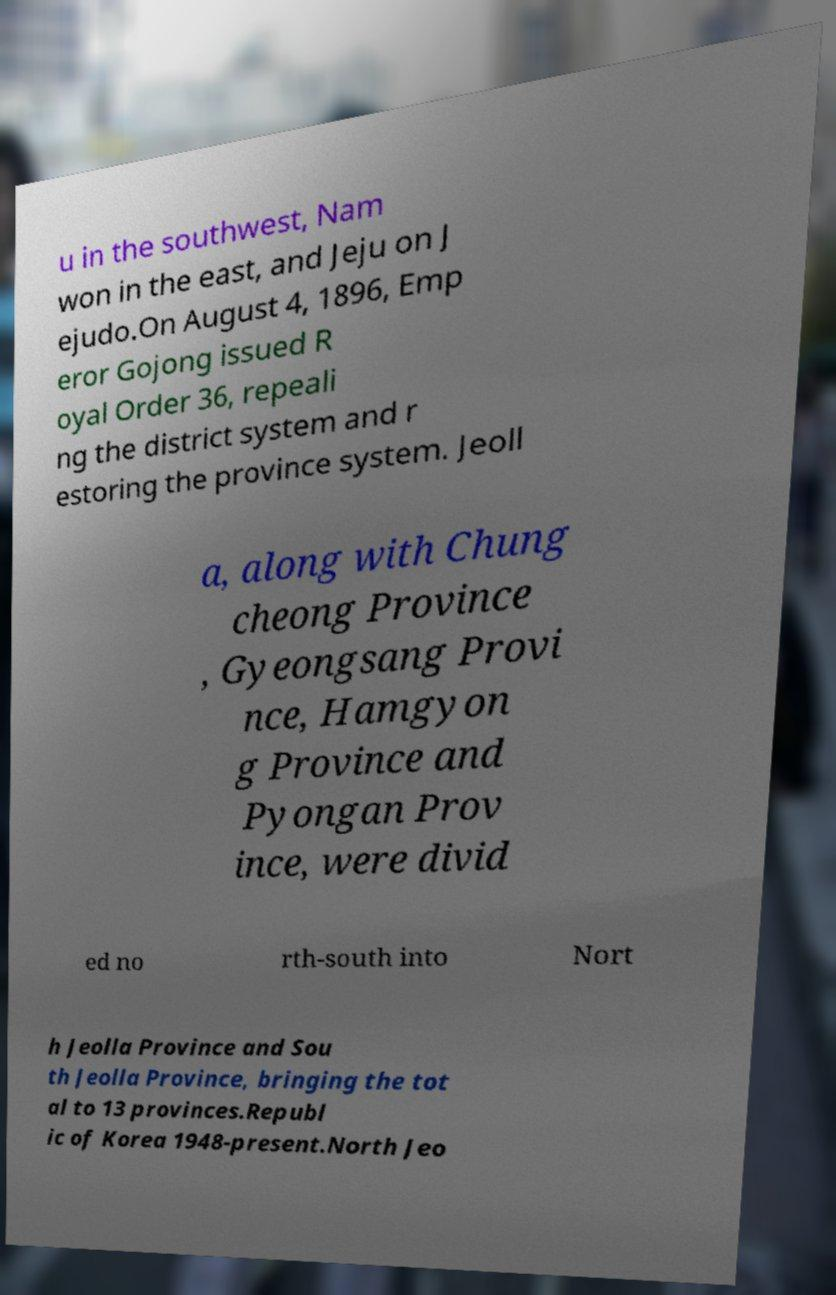For documentation purposes, I need the text within this image transcribed. Could you provide that? u in the southwest, Nam won in the east, and Jeju on J ejudo.On August 4, 1896, Emp eror Gojong issued R oyal Order 36, repeali ng the district system and r estoring the province system. Jeoll a, along with Chung cheong Province , Gyeongsang Provi nce, Hamgyon g Province and Pyongan Prov ince, were divid ed no rth-south into Nort h Jeolla Province and Sou th Jeolla Province, bringing the tot al to 13 provinces.Republ ic of Korea 1948-present.North Jeo 